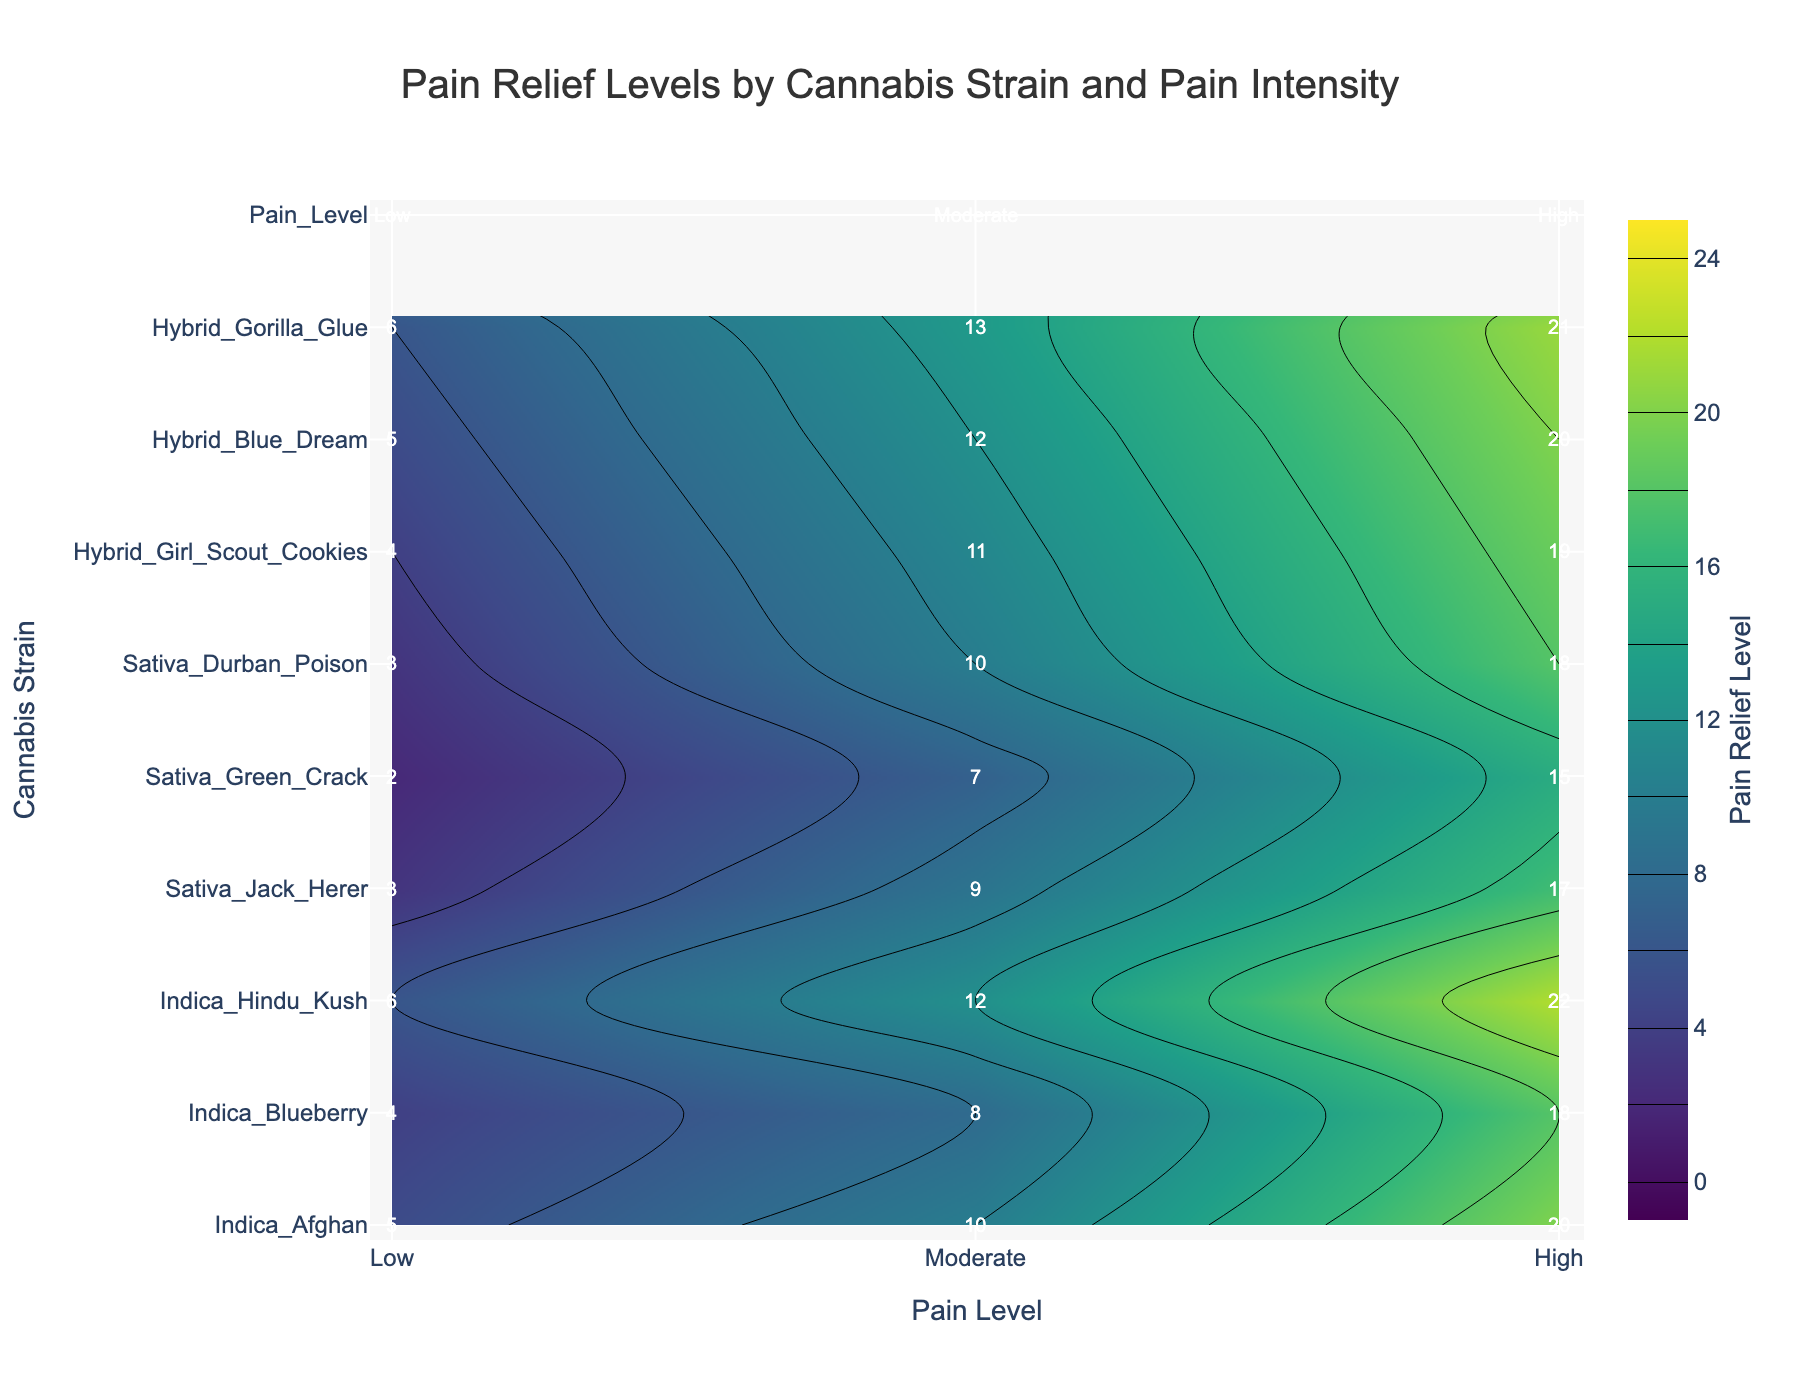What is the title of the figure? The title is located at the top center of the plot. It reads "Pain Relief Levels by Cannabis Strain and Pain Intensity."
Answer: Pain Relief Levels by Cannabis Strain and Pain Intensity Which cannabis strain shows the highest level of pain relief for high pain? By examining the contour plot and focusing on the "High" pain level column, the strain Indica Hindu Kush shows the highest pain relief at 22.
Answer: Indica Hindu Kush What is the color scale used in the figure? The figure uses the 'Viridis' color scale as it transitions from dark purple to yellow.
Answer: Viridis What is the average pain relief reported for Hybrid Blue Dream across all pain levels? The values for Hybrid Blue Dream are 5 for Low, 12 for Moderate, and 20 for High pain relief. Sum them up (5 + 12 + 20 = 37) and divide by 3 to find the average 37/3 = 12.33.
Answer: 12.33 Which cannabis strain shows the lowest pain relief for low pain levels, and what is the value? By examining the "Low" pain level column, the strain Sativa Green Crack shows the lowest pain relief, which is 2.
Answer: Sativa Green Crack, 2 How does the pain relief level for Indica Blueberry compare between moderate and high pain levels? For Indica Blueberry, the pain relief for moderate pain is 8 and for high pain is 18. The difference is 18 - 8 = 10.
Answer: The high pain relief is 10 units higher than moderate What is the total pain relief reported for all strains at the "Moderate" pain level? Sum the values for Moderate pain relief: 10 (Indica Afghan) + 8 (Indica Blueberry) + 12 (Indica Hindu Kush) + 9 (Sativa Jack Herer) + 7 (Sativa Green Crack) + 10 (Sativa Durban Poison) + 11 (Hybrid Girl Scout Cookies) + 12 (Hybrid Blue Dream) + 13 (Hybrid Gorilla Glue), which equals 92.
Answer: 92 How many cannabis strains are included in the figure? Count the number of unique strains on the y-axis; there are nine strains in total.
Answer: 9 Which category of cannabis strain, in general, shows the highest level of pain relief for high pain intensity? By comparing the values in the "High" pain level column, Indicas such as Afghan (20), Blueberry (18), and Hindu Kush (22) show the highest levels overall.
Answer: Indicas What is the difference in pain relief levels between Hybrid Gorilla Glue and Sativa Durban Poison for low pain? Hybrid Gorilla Glue has a low pain relief of 6, while Sativa Durban Poison has a relief of 3. The difference is 6 - 3 = 3.
Answer: 3 